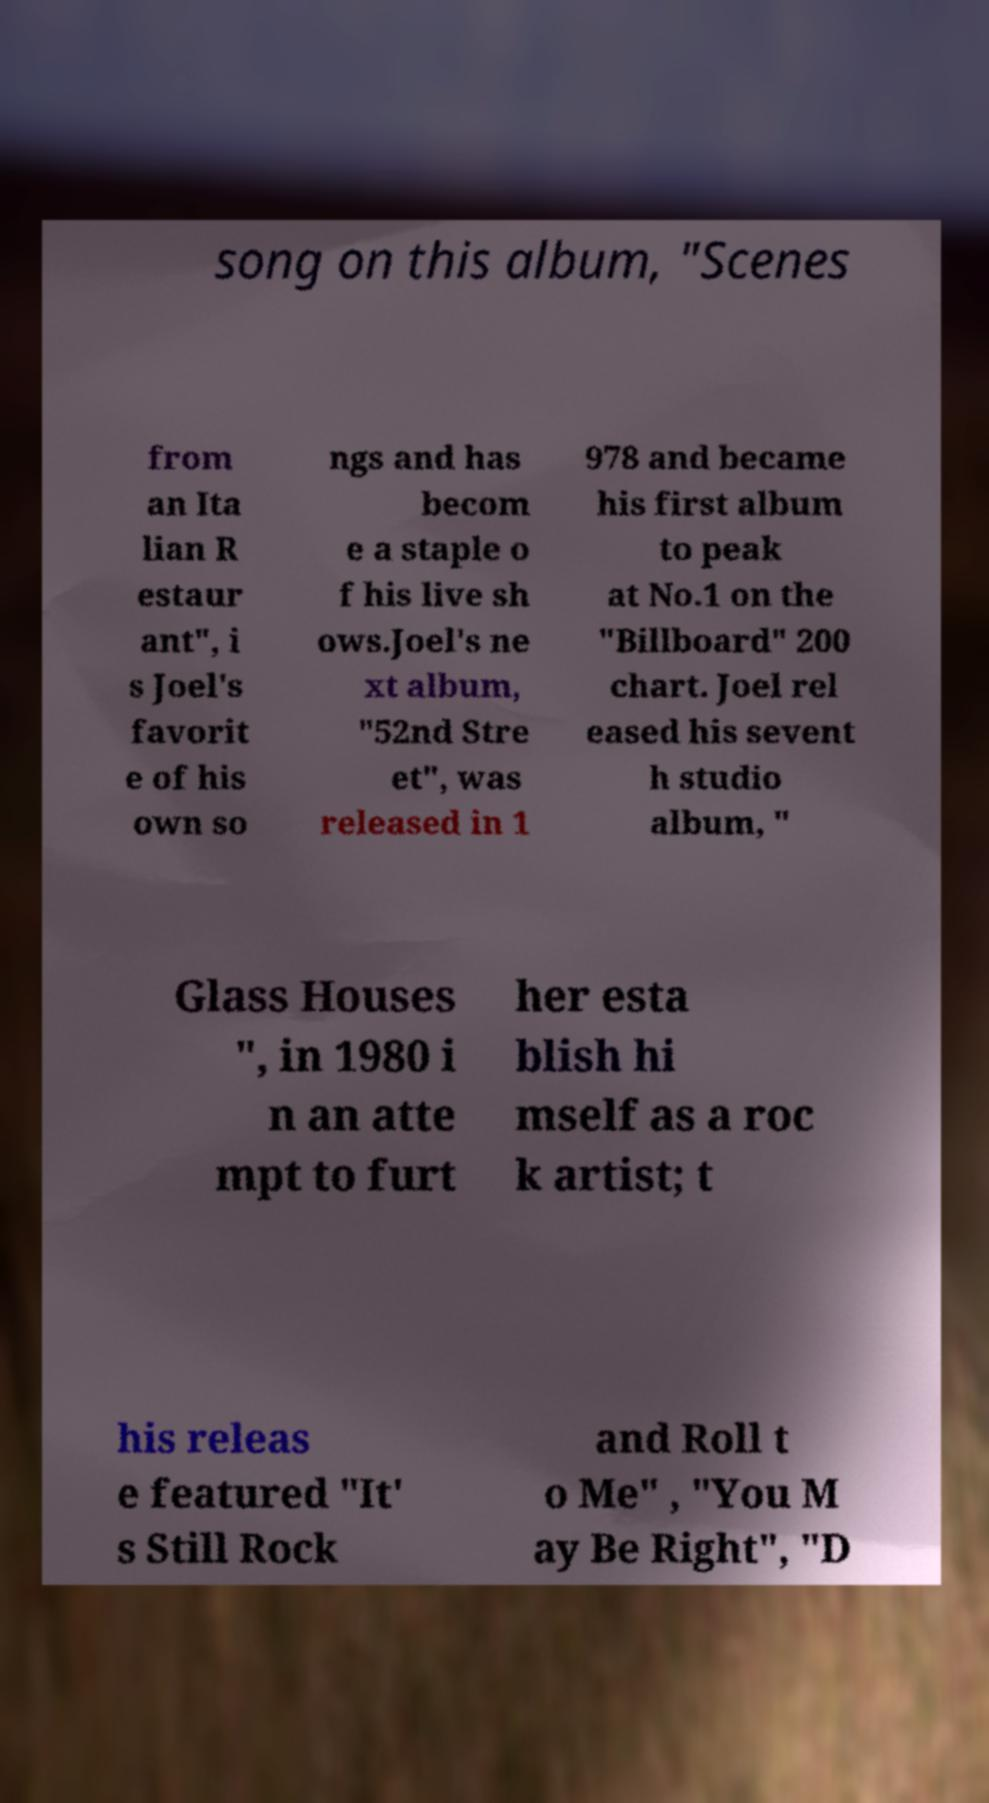What messages or text are displayed in this image? I need them in a readable, typed format. song on this album, "Scenes from an Ita lian R estaur ant", i s Joel's favorit e of his own so ngs and has becom e a staple o f his live sh ows.Joel's ne xt album, "52nd Stre et", was released in 1 978 and became his first album to peak at No.1 on the "Billboard" 200 chart. Joel rel eased his sevent h studio album, " Glass Houses ", in 1980 i n an atte mpt to furt her esta blish hi mself as a roc k artist; t his releas e featured "It' s Still Rock and Roll t o Me" , "You M ay Be Right", "D 